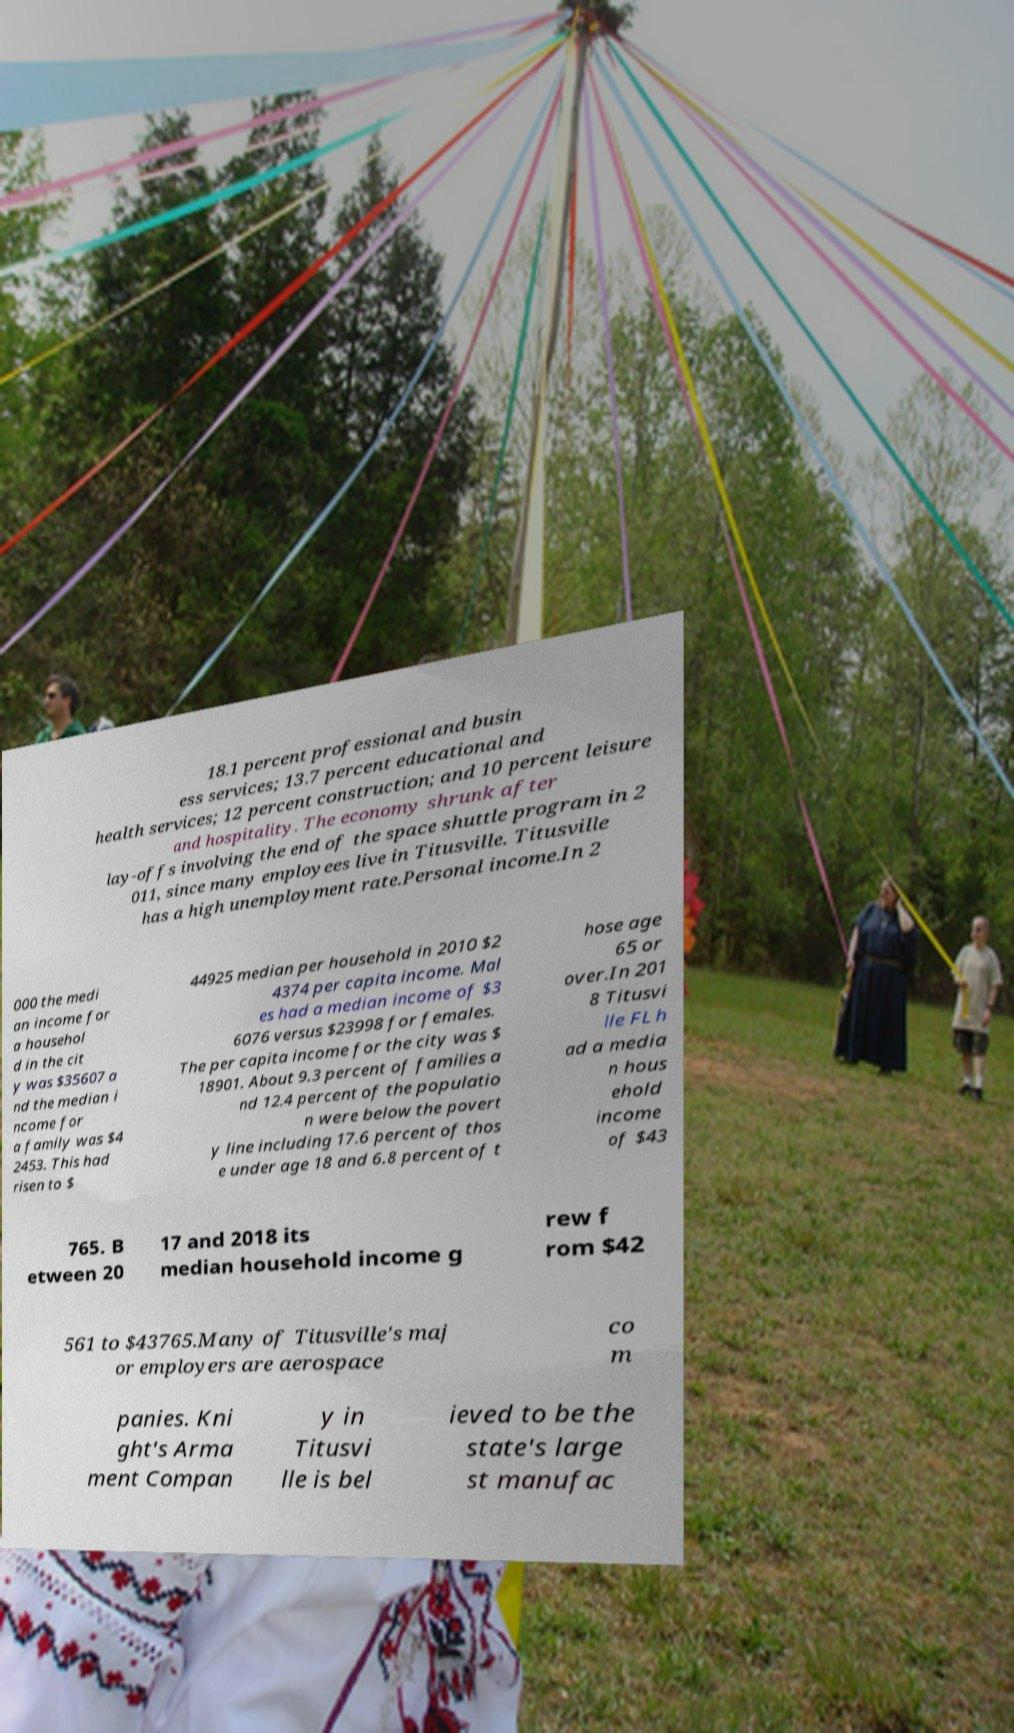Could you extract and type out the text from this image? 18.1 percent professional and busin ess services; 13.7 percent educational and health services; 12 percent construction; and 10 percent leisure and hospitality. The economy shrunk after lay-offs involving the end of the space shuttle program in 2 011, since many employees live in Titusville. Titusville has a high unemployment rate.Personal income.In 2 000 the medi an income for a househol d in the cit y was $35607 a nd the median i ncome for a family was $4 2453. This had risen to $ 44925 median per household in 2010 $2 4374 per capita income. Mal es had a median income of $3 6076 versus $23998 for females. The per capita income for the city was $ 18901. About 9.3 percent of families a nd 12.4 percent of the populatio n were below the povert y line including 17.6 percent of thos e under age 18 and 6.8 percent of t hose age 65 or over.In 201 8 Titusvi lle FL h ad a media n hous ehold income of $43 765. B etween 20 17 and 2018 its median household income g rew f rom $42 561 to $43765.Many of Titusville's maj or employers are aerospace co m panies. Kni ght's Arma ment Compan y in Titusvi lle is bel ieved to be the state's large st manufac 